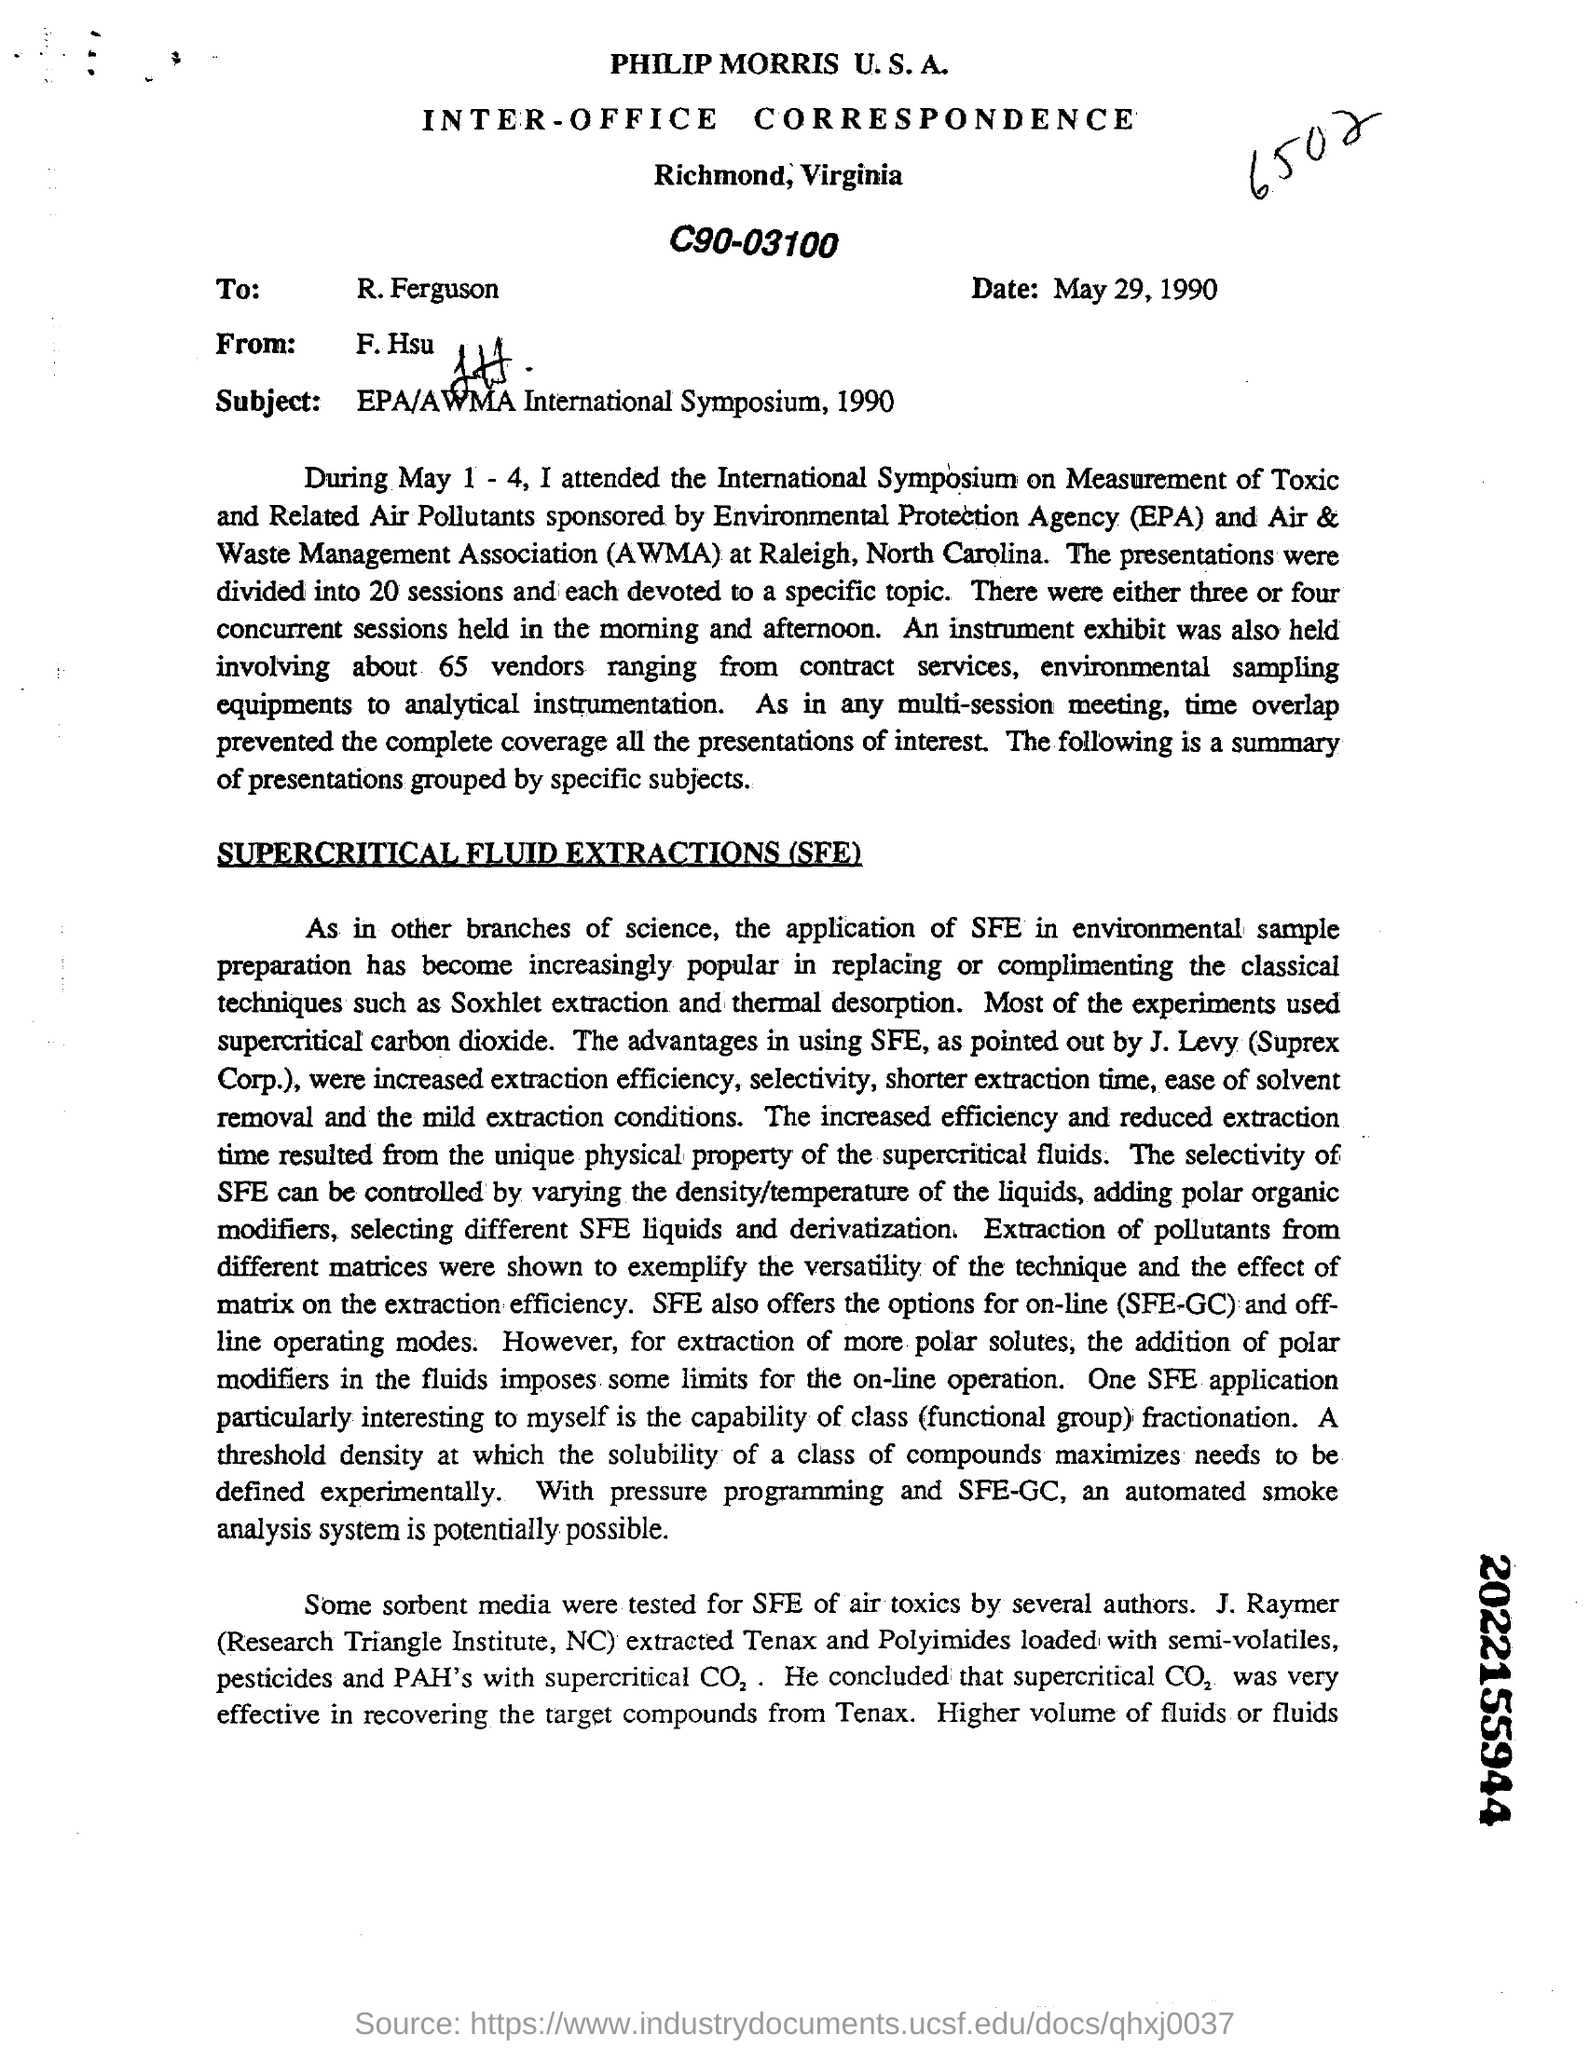Indicate a few pertinent items in this graphic. The subject of the document is the EPA/AWMA International Symposium that took place in 1990. The date mentioned is May 29, 1990. The 10-digit number mentioned in bold on the right margin, at the bottom, is 2022155944. The letter is addressed to R. Ferguson. 